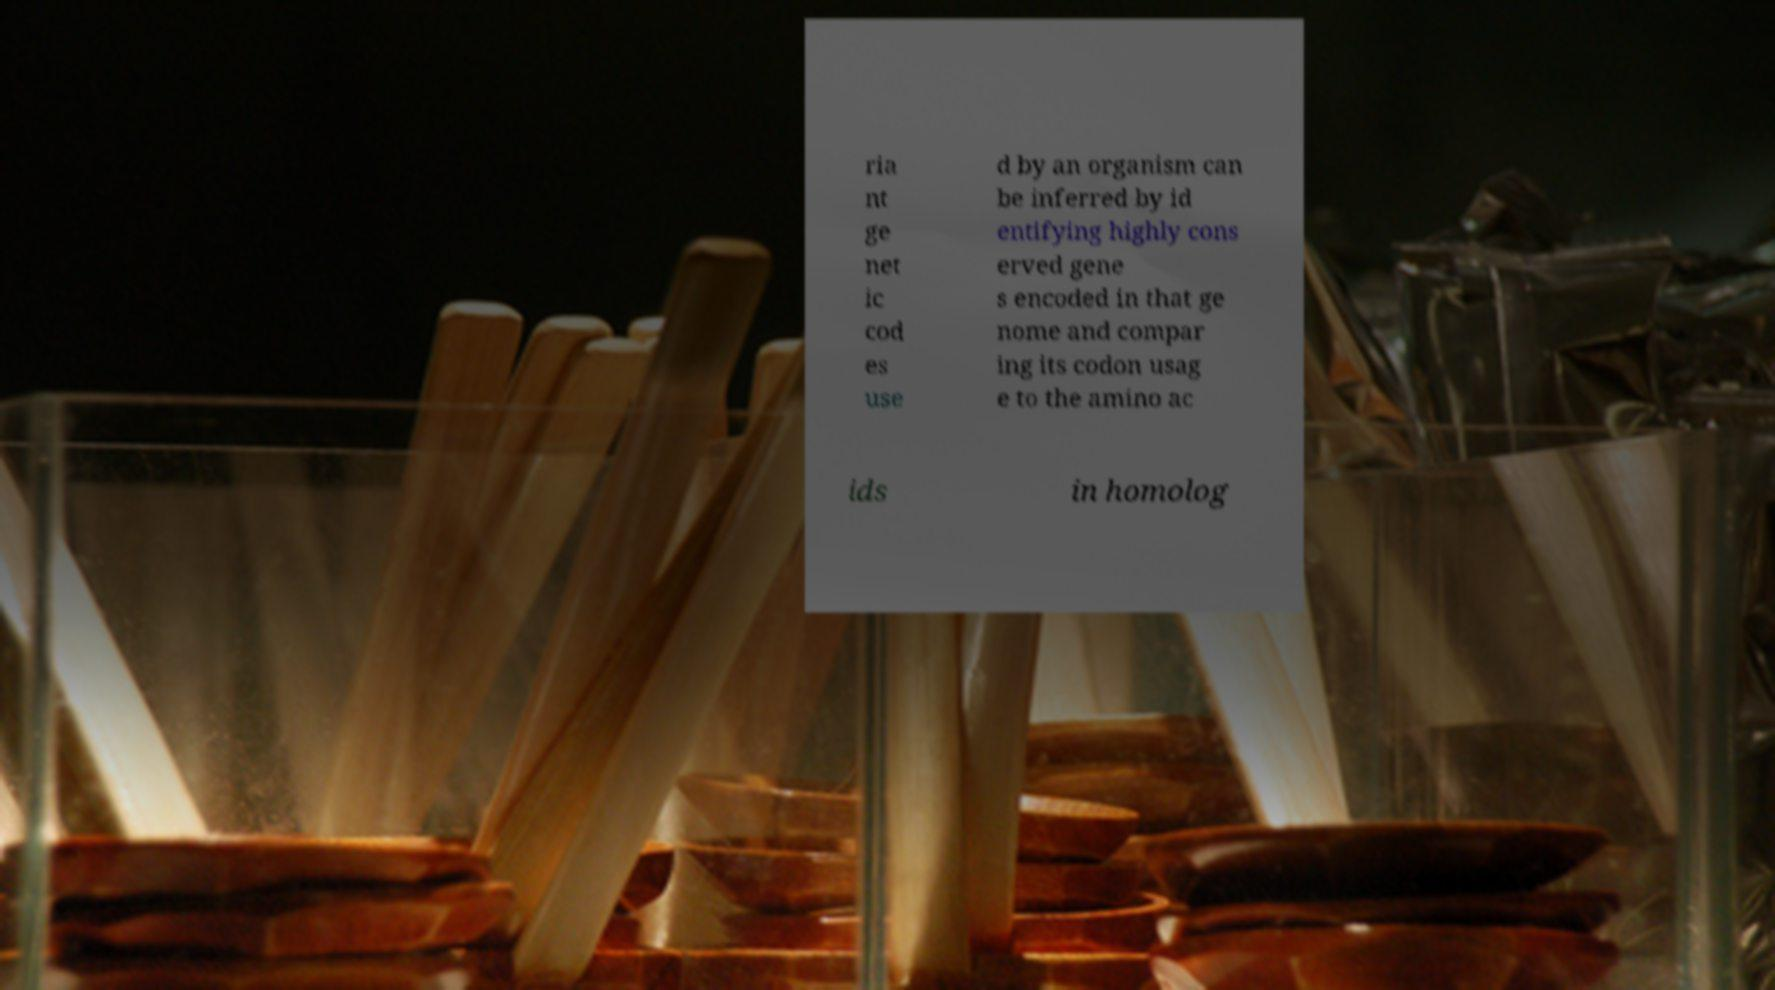Can you read and provide the text displayed in the image?This photo seems to have some interesting text. Can you extract and type it out for me? ria nt ge net ic cod es use d by an organism can be inferred by id entifying highly cons erved gene s encoded in that ge nome and compar ing its codon usag e to the amino ac ids in homolog 